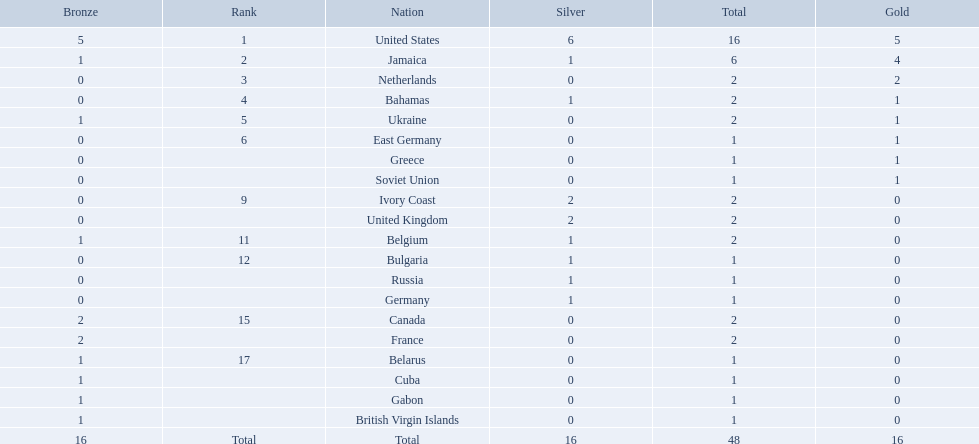Which countries participated? United States, Jamaica, Netherlands, Bahamas, Ukraine, East Germany, Greece, Soviet Union, Ivory Coast, United Kingdom, Belgium, Bulgaria, Russia, Germany, Canada, France, Belarus, Cuba, Gabon, British Virgin Islands. How many gold medals were won by each? 5, 4, 2, 1, 1, 1, 1, 1, 0, 0, 0, 0, 0, 0, 0, 0, 0, 0, 0, 0. And which country won the most? United States. What country won the most medals? United States. How many medals did the us win? 16. What is the most medals (after 16) that were won by a country? 6. Which country won 6 medals? Jamaica. Which countries competed in the 60 meters competition? United States, Jamaica, Netherlands, Bahamas, Ukraine, East Germany, Greece, Soviet Union, Ivory Coast, United Kingdom, Belgium, Bulgaria, Russia, Germany, Canada, France, Belarus, Cuba, Gabon, British Virgin Islands. And how many gold medals did they win? 5, 4, 2, 1, 1, 1, 1, 1, 0, 0, 0, 0, 0, 0, 0, 0, 0, 0, 0, 0. Of those countries, which won the second highest number gold medals? Jamaica. 